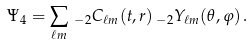<formula> <loc_0><loc_0><loc_500><loc_500>\Psi _ { 4 } = \sum _ { \ell m } \, _ { - 2 } C _ { \ell m } ( t , r ) \, _ { - 2 } Y _ { \ell m } ( \theta , \varphi ) \, .</formula> 